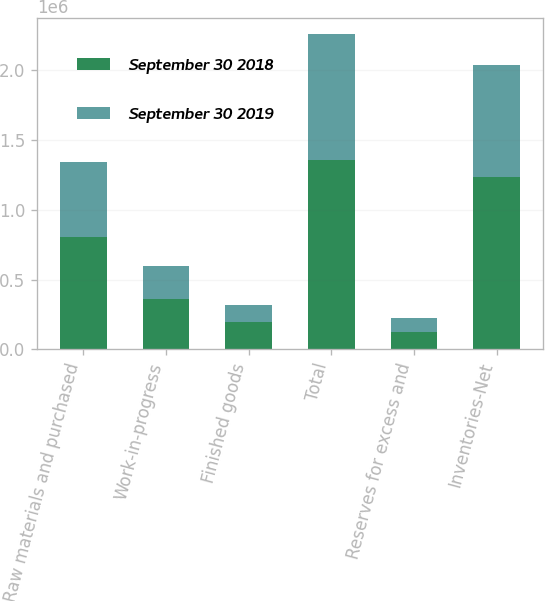Convert chart. <chart><loc_0><loc_0><loc_500><loc_500><stacked_bar_chart><ecel><fcel>Raw materials and purchased<fcel>Work-in-progress<fcel>Finished goods<fcel>Total<fcel>Reserves for excess and<fcel>Inventories-Net<nl><fcel>September 30 2018<fcel>804687<fcel>360230<fcel>191535<fcel>1.35645e+06<fcel>123803<fcel>1.23265e+06<nl><fcel>September 30 2019<fcel>540290<fcel>237335<fcel>127018<fcel>904643<fcel>99351<fcel>805292<nl></chart> 